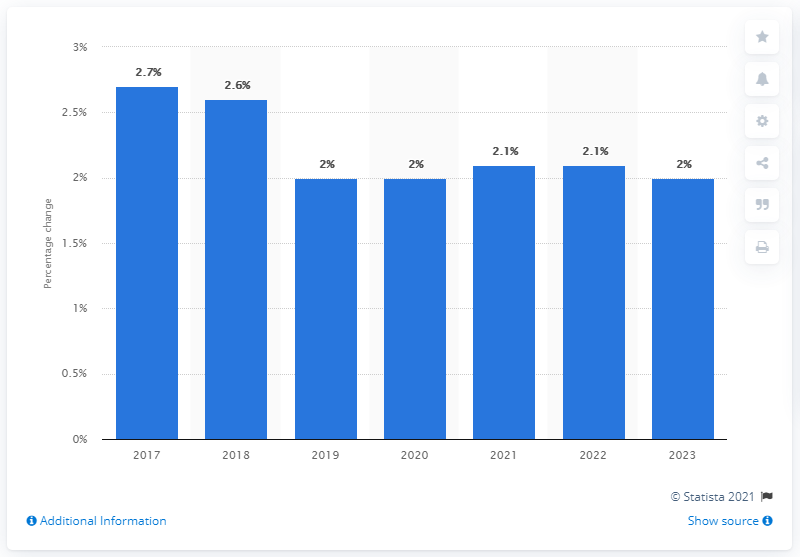Point out several critical features in this image. The Consumer Price Index of the UK is expected to change by a percentage between 2 and 2.1 percent in the year 2023. 